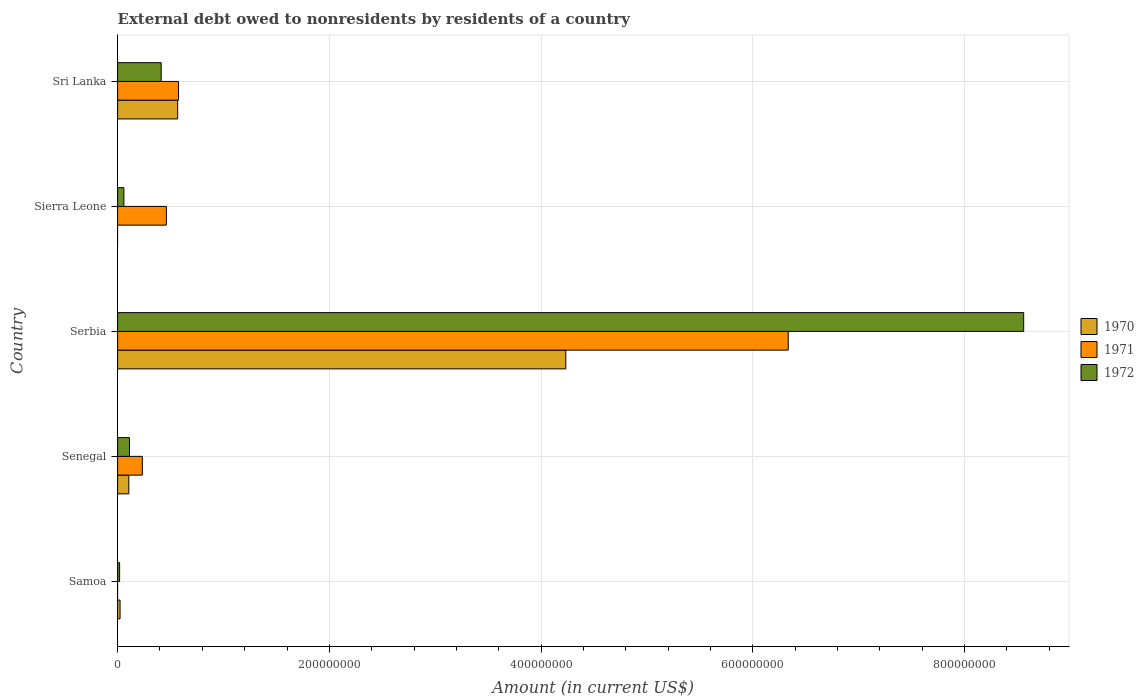How many groups of bars are there?
Offer a very short reply. 5. Are the number of bars per tick equal to the number of legend labels?
Provide a short and direct response. No. Are the number of bars on each tick of the Y-axis equal?
Provide a succinct answer. No. How many bars are there on the 5th tick from the top?
Offer a very short reply. 2. How many bars are there on the 5th tick from the bottom?
Your response must be concise. 3. What is the label of the 1st group of bars from the top?
Keep it short and to the point. Sri Lanka. What is the external debt owed by residents in 1971 in Samoa?
Provide a succinct answer. 0. Across all countries, what is the maximum external debt owed by residents in 1972?
Your response must be concise. 8.56e+08. In which country was the external debt owed by residents in 1971 maximum?
Give a very brief answer. Serbia. What is the total external debt owed by residents in 1972 in the graph?
Provide a short and direct response. 9.16e+08. What is the difference between the external debt owed by residents in 1972 in Sierra Leone and that in Sri Lanka?
Provide a succinct answer. -3.52e+07. What is the difference between the external debt owed by residents in 1971 in Sierra Leone and the external debt owed by residents in 1970 in Senegal?
Offer a very short reply. 3.55e+07. What is the average external debt owed by residents in 1970 per country?
Ensure brevity in your answer.  9.86e+07. What is the difference between the external debt owed by residents in 1972 and external debt owed by residents in 1971 in Sri Lanka?
Give a very brief answer. -1.64e+07. What is the ratio of the external debt owed by residents in 1971 in Serbia to that in Sierra Leone?
Your answer should be very brief. 13.75. Is the external debt owed by residents in 1970 in Samoa less than that in Serbia?
Give a very brief answer. Yes. What is the difference between the highest and the second highest external debt owed by residents in 1970?
Ensure brevity in your answer.  3.67e+08. What is the difference between the highest and the lowest external debt owed by residents in 1970?
Offer a very short reply. 4.23e+08. How many bars are there?
Offer a terse response. 13. How many countries are there in the graph?
Your answer should be compact. 5. What is the difference between two consecutive major ticks on the X-axis?
Give a very brief answer. 2.00e+08. Does the graph contain grids?
Offer a very short reply. Yes. How are the legend labels stacked?
Give a very brief answer. Vertical. What is the title of the graph?
Provide a short and direct response. External debt owed to nonresidents by residents of a country. What is the label or title of the X-axis?
Give a very brief answer. Amount (in current US$). What is the Amount (in current US$) in 1970 in Samoa?
Your answer should be very brief. 2.32e+06. What is the Amount (in current US$) in 1971 in Samoa?
Your response must be concise. 0. What is the Amount (in current US$) in 1972 in Samoa?
Your answer should be compact. 1.89e+06. What is the Amount (in current US$) in 1970 in Senegal?
Provide a succinct answer. 1.06e+07. What is the Amount (in current US$) in 1971 in Senegal?
Offer a very short reply. 2.34e+07. What is the Amount (in current US$) in 1972 in Senegal?
Your answer should be compact. 1.12e+07. What is the Amount (in current US$) in 1970 in Serbia?
Your answer should be very brief. 4.23e+08. What is the Amount (in current US$) of 1971 in Serbia?
Provide a succinct answer. 6.33e+08. What is the Amount (in current US$) of 1972 in Serbia?
Your answer should be compact. 8.56e+08. What is the Amount (in current US$) of 1970 in Sierra Leone?
Provide a succinct answer. 0. What is the Amount (in current US$) in 1971 in Sierra Leone?
Make the answer very short. 4.61e+07. What is the Amount (in current US$) of 1972 in Sierra Leone?
Make the answer very short. 5.94e+06. What is the Amount (in current US$) in 1970 in Sri Lanka?
Ensure brevity in your answer.  5.67e+07. What is the Amount (in current US$) in 1971 in Sri Lanka?
Make the answer very short. 5.76e+07. What is the Amount (in current US$) in 1972 in Sri Lanka?
Provide a short and direct response. 4.12e+07. Across all countries, what is the maximum Amount (in current US$) of 1970?
Give a very brief answer. 4.23e+08. Across all countries, what is the maximum Amount (in current US$) in 1971?
Provide a short and direct response. 6.33e+08. Across all countries, what is the maximum Amount (in current US$) in 1972?
Offer a terse response. 8.56e+08. Across all countries, what is the minimum Amount (in current US$) in 1972?
Provide a succinct answer. 1.89e+06. What is the total Amount (in current US$) in 1970 in the graph?
Your answer should be compact. 4.93e+08. What is the total Amount (in current US$) of 1971 in the graph?
Your response must be concise. 7.60e+08. What is the total Amount (in current US$) of 1972 in the graph?
Provide a short and direct response. 9.16e+08. What is the difference between the Amount (in current US$) in 1970 in Samoa and that in Senegal?
Make the answer very short. -8.28e+06. What is the difference between the Amount (in current US$) in 1972 in Samoa and that in Senegal?
Your answer should be very brief. -9.34e+06. What is the difference between the Amount (in current US$) in 1970 in Samoa and that in Serbia?
Ensure brevity in your answer.  -4.21e+08. What is the difference between the Amount (in current US$) in 1972 in Samoa and that in Serbia?
Your answer should be compact. -8.54e+08. What is the difference between the Amount (in current US$) of 1972 in Samoa and that in Sierra Leone?
Your answer should be very brief. -4.05e+06. What is the difference between the Amount (in current US$) of 1970 in Samoa and that in Sri Lanka?
Keep it short and to the point. -5.44e+07. What is the difference between the Amount (in current US$) of 1972 in Samoa and that in Sri Lanka?
Ensure brevity in your answer.  -3.93e+07. What is the difference between the Amount (in current US$) in 1970 in Senegal and that in Serbia?
Offer a terse response. -4.13e+08. What is the difference between the Amount (in current US$) of 1971 in Senegal and that in Serbia?
Your response must be concise. -6.10e+08. What is the difference between the Amount (in current US$) of 1972 in Senegal and that in Serbia?
Give a very brief answer. -8.45e+08. What is the difference between the Amount (in current US$) of 1971 in Senegal and that in Sierra Leone?
Ensure brevity in your answer.  -2.27e+07. What is the difference between the Amount (in current US$) of 1972 in Senegal and that in Sierra Leone?
Your answer should be very brief. 5.29e+06. What is the difference between the Amount (in current US$) of 1970 in Senegal and that in Sri Lanka?
Keep it short and to the point. -4.61e+07. What is the difference between the Amount (in current US$) in 1971 in Senegal and that in Sri Lanka?
Make the answer very short. -3.42e+07. What is the difference between the Amount (in current US$) in 1972 in Senegal and that in Sri Lanka?
Your answer should be compact. -2.99e+07. What is the difference between the Amount (in current US$) in 1971 in Serbia and that in Sierra Leone?
Your response must be concise. 5.87e+08. What is the difference between the Amount (in current US$) in 1972 in Serbia and that in Sierra Leone?
Make the answer very short. 8.50e+08. What is the difference between the Amount (in current US$) of 1970 in Serbia and that in Sri Lanka?
Offer a very short reply. 3.67e+08. What is the difference between the Amount (in current US$) of 1971 in Serbia and that in Sri Lanka?
Provide a succinct answer. 5.76e+08. What is the difference between the Amount (in current US$) in 1972 in Serbia and that in Sri Lanka?
Give a very brief answer. 8.15e+08. What is the difference between the Amount (in current US$) of 1971 in Sierra Leone and that in Sri Lanka?
Keep it short and to the point. -1.15e+07. What is the difference between the Amount (in current US$) of 1972 in Sierra Leone and that in Sri Lanka?
Ensure brevity in your answer.  -3.52e+07. What is the difference between the Amount (in current US$) in 1970 in Samoa and the Amount (in current US$) in 1971 in Senegal?
Your response must be concise. -2.10e+07. What is the difference between the Amount (in current US$) in 1970 in Samoa and the Amount (in current US$) in 1972 in Senegal?
Give a very brief answer. -8.91e+06. What is the difference between the Amount (in current US$) in 1970 in Samoa and the Amount (in current US$) in 1971 in Serbia?
Give a very brief answer. -6.31e+08. What is the difference between the Amount (in current US$) of 1970 in Samoa and the Amount (in current US$) of 1972 in Serbia?
Provide a succinct answer. -8.54e+08. What is the difference between the Amount (in current US$) in 1970 in Samoa and the Amount (in current US$) in 1971 in Sierra Leone?
Provide a short and direct response. -4.37e+07. What is the difference between the Amount (in current US$) of 1970 in Samoa and the Amount (in current US$) of 1972 in Sierra Leone?
Give a very brief answer. -3.61e+06. What is the difference between the Amount (in current US$) in 1970 in Samoa and the Amount (in current US$) in 1971 in Sri Lanka?
Offer a very short reply. -5.52e+07. What is the difference between the Amount (in current US$) in 1970 in Samoa and the Amount (in current US$) in 1972 in Sri Lanka?
Keep it short and to the point. -3.88e+07. What is the difference between the Amount (in current US$) in 1970 in Senegal and the Amount (in current US$) in 1971 in Serbia?
Ensure brevity in your answer.  -6.23e+08. What is the difference between the Amount (in current US$) of 1970 in Senegal and the Amount (in current US$) of 1972 in Serbia?
Give a very brief answer. -8.45e+08. What is the difference between the Amount (in current US$) in 1971 in Senegal and the Amount (in current US$) in 1972 in Serbia?
Ensure brevity in your answer.  -8.32e+08. What is the difference between the Amount (in current US$) of 1970 in Senegal and the Amount (in current US$) of 1971 in Sierra Leone?
Provide a short and direct response. -3.55e+07. What is the difference between the Amount (in current US$) of 1970 in Senegal and the Amount (in current US$) of 1972 in Sierra Leone?
Your answer should be very brief. 4.66e+06. What is the difference between the Amount (in current US$) in 1971 in Senegal and the Amount (in current US$) in 1972 in Sierra Leone?
Give a very brief answer. 1.74e+07. What is the difference between the Amount (in current US$) in 1970 in Senegal and the Amount (in current US$) in 1971 in Sri Lanka?
Your answer should be compact. -4.70e+07. What is the difference between the Amount (in current US$) in 1970 in Senegal and the Amount (in current US$) in 1972 in Sri Lanka?
Your answer should be very brief. -3.06e+07. What is the difference between the Amount (in current US$) in 1971 in Senegal and the Amount (in current US$) in 1972 in Sri Lanka?
Ensure brevity in your answer.  -1.78e+07. What is the difference between the Amount (in current US$) in 1970 in Serbia and the Amount (in current US$) in 1971 in Sierra Leone?
Make the answer very short. 3.77e+08. What is the difference between the Amount (in current US$) in 1970 in Serbia and the Amount (in current US$) in 1972 in Sierra Leone?
Give a very brief answer. 4.17e+08. What is the difference between the Amount (in current US$) of 1971 in Serbia and the Amount (in current US$) of 1972 in Sierra Leone?
Give a very brief answer. 6.28e+08. What is the difference between the Amount (in current US$) in 1970 in Serbia and the Amount (in current US$) in 1971 in Sri Lanka?
Your response must be concise. 3.66e+08. What is the difference between the Amount (in current US$) of 1970 in Serbia and the Amount (in current US$) of 1972 in Sri Lanka?
Provide a short and direct response. 3.82e+08. What is the difference between the Amount (in current US$) in 1971 in Serbia and the Amount (in current US$) in 1972 in Sri Lanka?
Offer a terse response. 5.92e+08. What is the difference between the Amount (in current US$) in 1971 in Sierra Leone and the Amount (in current US$) in 1972 in Sri Lanka?
Your answer should be compact. 4.91e+06. What is the average Amount (in current US$) of 1970 per country?
Your answer should be compact. 9.86e+07. What is the average Amount (in current US$) in 1971 per country?
Offer a very short reply. 1.52e+08. What is the average Amount (in current US$) in 1972 per country?
Your answer should be very brief. 1.83e+08. What is the difference between the Amount (in current US$) of 1970 and Amount (in current US$) of 1972 in Samoa?
Your answer should be very brief. 4.36e+05. What is the difference between the Amount (in current US$) in 1970 and Amount (in current US$) in 1971 in Senegal?
Give a very brief answer. -1.28e+07. What is the difference between the Amount (in current US$) in 1970 and Amount (in current US$) in 1972 in Senegal?
Your response must be concise. -6.30e+05. What is the difference between the Amount (in current US$) in 1971 and Amount (in current US$) in 1972 in Senegal?
Give a very brief answer. 1.21e+07. What is the difference between the Amount (in current US$) of 1970 and Amount (in current US$) of 1971 in Serbia?
Make the answer very short. -2.10e+08. What is the difference between the Amount (in current US$) in 1970 and Amount (in current US$) in 1972 in Serbia?
Provide a succinct answer. -4.32e+08. What is the difference between the Amount (in current US$) in 1971 and Amount (in current US$) in 1972 in Serbia?
Keep it short and to the point. -2.22e+08. What is the difference between the Amount (in current US$) in 1971 and Amount (in current US$) in 1972 in Sierra Leone?
Make the answer very short. 4.01e+07. What is the difference between the Amount (in current US$) in 1970 and Amount (in current US$) in 1971 in Sri Lanka?
Ensure brevity in your answer.  -8.21e+05. What is the difference between the Amount (in current US$) of 1970 and Amount (in current US$) of 1972 in Sri Lanka?
Give a very brief answer. 1.56e+07. What is the difference between the Amount (in current US$) in 1971 and Amount (in current US$) in 1972 in Sri Lanka?
Your response must be concise. 1.64e+07. What is the ratio of the Amount (in current US$) of 1970 in Samoa to that in Senegal?
Ensure brevity in your answer.  0.22. What is the ratio of the Amount (in current US$) of 1972 in Samoa to that in Senegal?
Your answer should be very brief. 0.17. What is the ratio of the Amount (in current US$) of 1970 in Samoa to that in Serbia?
Ensure brevity in your answer.  0.01. What is the ratio of the Amount (in current US$) in 1972 in Samoa to that in Serbia?
Your response must be concise. 0. What is the ratio of the Amount (in current US$) of 1972 in Samoa to that in Sierra Leone?
Offer a terse response. 0.32. What is the ratio of the Amount (in current US$) of 1970 in Samoa to that in Sri Lanka?
Ensure brevity in your answer.  0.04. What is the ratio of the Amount (in current US$) of 1972 in Samoa to that in Sri Lanka?
Offer a very short reply. 0.05. What is the ratio of the Amount (in current US$) of 1970 in Senegal to that in Serbia?
Provide a short and direct response. 0.03. What is the ratio of the Amount (in current US$) in 1971 in Senegal to that in Serbia?
Your response must be concise. 0.04. What is the ratio of the Amount (in current US$) in 1972 in Senegal to that in Serbia?
Your answer should be very brief. 0.01. What is the ratio of the Amount (in current US$) of 1971 in Senegal to that in Sierra Leone?
Your answer should be very brief. 0.51. What is the ratio of the Amount (in current US$) in 1972 in Senegal to that in Sierra Leone?
Make the answer very short. 1.89. What is the ratio of the Amount (in current US$) of 1970 in Senegal to that in Sri Lanka?
Your answer should be very brief. 0.19. What is the ratio of the Amount (in current US$) in 1971 in Senegal to that in Sri Lanka?
Provide a succinct answer. 0.41. What is the ratio of the Amount (in current US$) of 1972 in Senegal to that in Sri Lanka?
Your answer should be compact. 0.27. What is the ratio of the Amount (in current US$) of 1971 in Serbia to that in Sierra Leone?
Your response must be concise. 13.75. What is the ratio of the Amount (in current US$) in 1972 in Serbia to that in Sierra Leone?
Your response must be concise. 144.15. What is the ratio of the Amount (in current US$) in 1970 in Serbia to that in Sri Lanka?
Keep it short and to the point. 7.46. What is the ratio of the Amount (in current US$) of 1971 in Serbia to that in Sri Lanka?
Offer a terse response. 11.01. What is the ratio of the Amount (in current US$) of 1972 in Serbia to that in Sri Lanka?
Your response must be concise. 20.8. What is the ratio of the Amount (in current US$) in 1971 in Sierra Leone to that in Sri Lanka?
Give a very brief answer. 0.8. What is the ratio of the Amount (in current US$) in 1972 in Sierra Leone to that in Sri Lanka?
Your answer should be very brief. 0.14. What is the difference between the highest and the second highest Amount (in current US$) in 1970?
Provide a short and direct response. 3.67e+08. What is the difference between the highest and the second highest Amount (in current US$) in 1971?
Provide a short and direct response. 5.76e+08. What is the difference between the highest and the second highest Amount (in current US$) of 1972?
Your answer should be very brief. 8.15e+08. What is the difference between the highest and the lowest Amount (in current US$) in 1970?
Make the answer very short. 4.23e+08. What is the difference between the highest and the lowest Amount (in current US$) of 1971?
Keep it short and to the point. 6.33e+08. What is the difference between the highest and the lowest Amount (in current US$) of 1972?
Ensure brevity in your answer.  8.54e+08. 